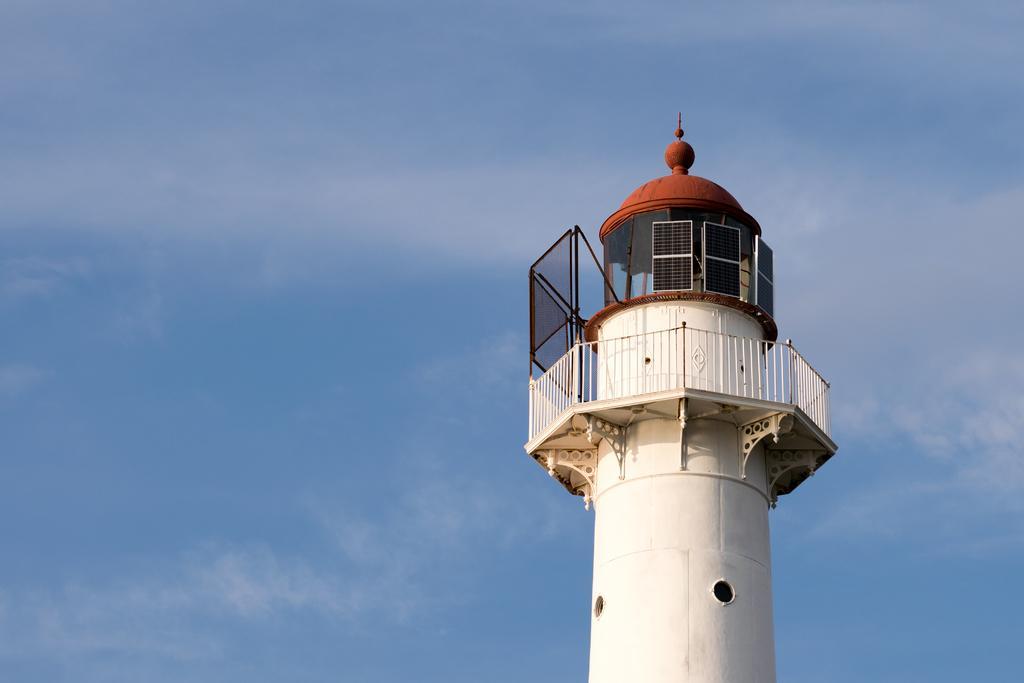Please provide a concise description of this image. In this image I can see the tower which is cream, black and brown in color and I can see the white colored railing around the tower. In the background I can see the sky. 